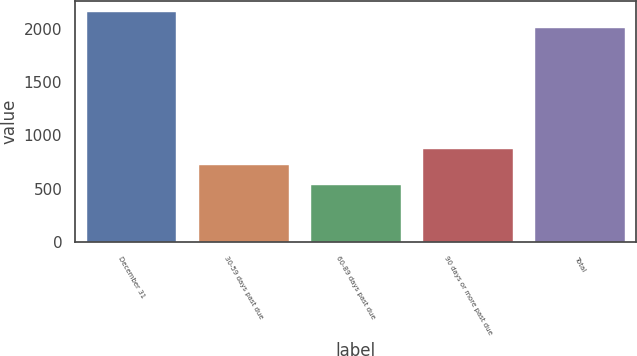Convert chart to OTSL. <chart><loc_0><loc_0><loc_500><loc_500><bar_chart><fcel>December 31<fcel>30-59 days past due<fcel>60-89 days past due<fcel>90 days or more past due<fcel>Total<nl><fcel>2157.4<fcel>721<fcel>531<fcel>869.4<fcel>2009<nl></chart> 